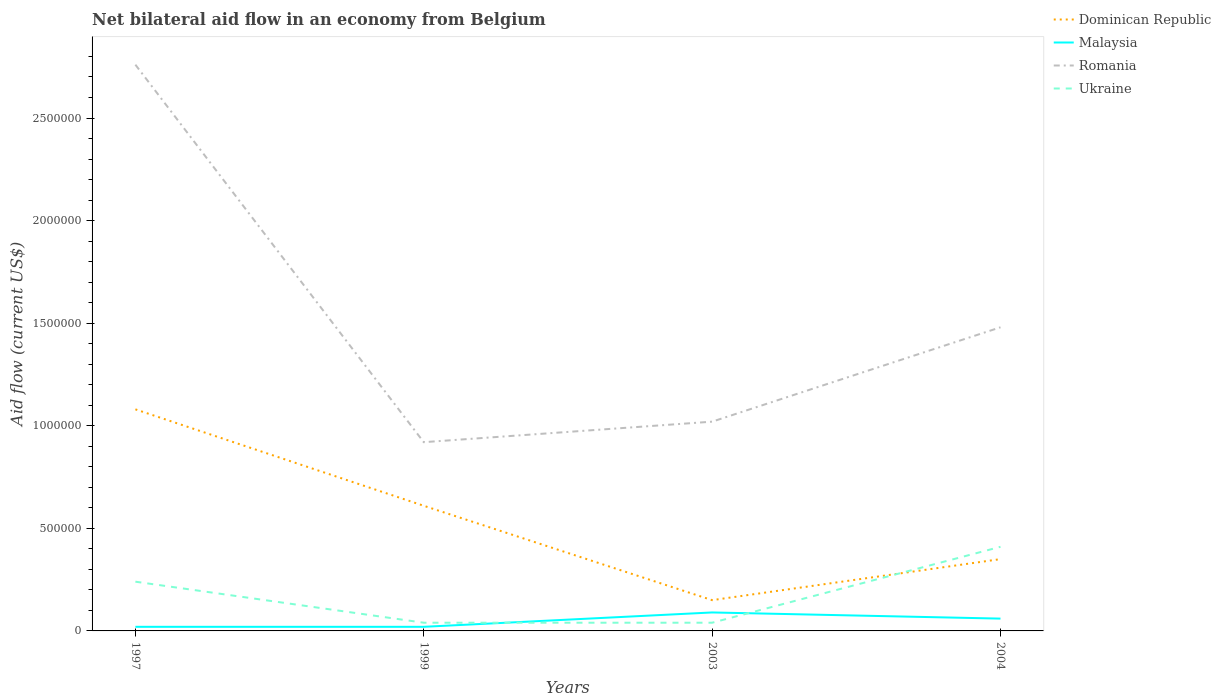Does the line corresponding to Malaysia intersect with the line corresponding to Dominican Republic?
Ensure brevity in your answer.  No. What is the total net bilateral aid flow in Romania in the graph?
Your answer should be compact. 1.84e+06. What is the difference between the highest and the second highest net bilateral aid flow in Romania?
Offer a terse response. 1.84e+06. Is the net bilateral aid flow in Ukraine strictly greater than the net bilateral aid flow in Dominican Republic over the years?
Provide a succinct answer. No. What is the difference between two consecutive major ticks on the Y-axis?
Give a very brief answer. 5.00e+05. Does the graph contain grids?
Make the answer very short. No. Where does the legend appear in the graph?
Your answer should be compact. Top right. How many legend labels are there?
Ensure brevity in your answer.  4. What is the title of the graph?
Your answer should be compact. Net bilateral aid flow in an economy from Belgium. Does "Lesotho" appear as one of the legend labels in the graph?
Give a very brief answer. No. What is the label or title of the X-axis?
Your answer should be very brief. Years. What is the Aid flow (current US$) in Dominican Republic in 1997?
Offer a terse response. 1.08e+06. What is the Aid flow (current US$) in Romania in 1997?
Provide a short and direct response. 2.76e+06. What is the Aid flow (current US$) of Romania in 1999?
Provide a succinct answer. 9.20e+05. What is the Aid flow (current US$) of Ukraine in 1999?
Keep it short and to the point. 4.00e+04. What is the Aid flow (current US$) in Dominican Republic in 2003?
Offer a very short reply. 1.50e+05. What is the Aid flow (current US$) in Romania in 2003?
Your answer should be very brief. 1.02e+06. What is the Aid flow (current US$) of Dominican Republic in 2004?
Give a very brief answer. 3.50e+05. What is the Aid flow (current US$) in Malaysia in 2004?
Make the answer very short. 6.00e+04. What is the Aid flow (current US$) in Romania in 2004?
Your answer should be very brief. 1.48e+06. Across all years, what is the maximum Aid flow (current US$) in Dominican Republic?
Your answer should be very brief. 1.08e+06. Across all years, what is the maximum Aid flow (current US$) of Malaysia?
Provide a succinct answer. 9.00e+04. Across all years, what is the maximum Aid flow (current US$) in Romania?
Keep it short and to the point. 2.76e+06. Across all years, what is the maximum Aid flow (current US$) in Ukraine?
Offer a very short reply. 4.10e+05. Across all years, what is the minimum Aid flow (current US$) of Dominican Republic?
Keep it short and to the point. 1.50e+05. Across all years, what is the minimum Aid flow (current US$) of Malaysia?
Provide a succinct answer. 2.00e+04. Across all years, what is the minimum Aid flow (current US$) in Romania?
Ensure brevity in your answer.  9.20e+05. Across all years, what is the minimum Aid flow (current US$) of Ukraine?
Ensure brevity in your answer.  4.00e+04. What is the total Aid flow (current US$) in Dominican Republic in the graph?
Offer a terse response. 2.19e+06. What is the total Aid flow (current US$) of Malaysia in the graph?
Ensure brevity in your answer.  1.90e+05. What is the total Aid flow (current US$) in Romania in the graph?
Keep it short and to the point. 6.18e+06. What is the total Aid flow (current US$) in Ukraine in the graph?
Give a very brief answer. 7.30e+05. What is the difference between the Aid flow (current US$) in Dominican Republic in 1997 and that in 1999?
Your response must be concise. 4.70e+05. What is the difference between the Aid flow (current US$) of Romania in 1997 and that in 1999?
Keep it short and to the point. 1.84e+06. What is the difference between the Aid flow (current US$) in Ukraine in 1997 and that in 1999?
Your response must be concise. 2.00e+05. What is the difference between the Aid flow (current US$) in Dominican Republic in 1997 and that in 2003?
Your response must be concise. 9.30e+05. What is the difference between the Aid flow (current US$) of Malaysia in 1997 and that in 2003?
Make the answer very short. -7.00e+04. What is the difference between the Aid flow (current US$) in Romania in 1997 and that in 2003?
Give a very brief answer. 1.74e+06. What is the difference between the Aid flow (current US$) in Ukraine in 1997 and that in 2003?
Your response must be concise. 2.00e+05. What is the difference between the Aid flow (current US$) of Dominican Republic in 1997 and that in 2004?
Make the answer very short. 7.30e+05. What is the difference between the Aid flow (current US$) of Romania in 1997 and that in 2004?
Ensure brevity in your answer.  1.28e+06. What is the difference between the Aid flow (current US$) in Dominican Republic in 1999 and that in 2003?
Provide a succinct answer. 4.60e+05. What is the difference between the Aid flow (current US$) in Romania in 1999 and that in 2003?
Offer a very short reply. -1.00e+05. What is the difference between the Aid flow (current US$) of Ukraine in 1999 and that in 2003?
Provide a succinct answer. 0. What is the difference between the Aid flow (current US$) of Malaysia in 1999 and that in 2004?
Give a very brief answer. -4.00e+04. What is the difference between the Aid flow (current US$) in Romania in 1999 and that in 2004?
Provide a succinct answer. -5.60e+05. What is the difference between the Aid flow (current US$) of Ukraine in 1999 and that in 2004?
Give a very brief answer. -3.70e+05. What is the difference between the Aid flow (current US$) of Dominican Republic in 2003 and that in 2004?
Keep it short and to the point. -2.00e+05. What is the difference between the Aid flow (current US$) of Malaysia in 2003 and that in 2004?
Your response must be concise. 3.00e+04. What is the difference between the Aid flow (current US$) in Romania in 2003 and that in 2004?
Ensure brevity in your answer.  -4.60e+05. What is the difference between the Aid flow (current US$) of Ukraine in 2003 and that in 2004?
Provide a succinct answer. -3.70e+05. What is the difference between the Aid flow (current US$) of Dominican Republic in 1997 and the Aid flow (current US$) of Malaysia in 1999?
Make the answer very short. 1.06e+06. What is the difference between the Aid flow (current US$) of Dominican Republic in 1997 and the Aid flow (current US$) of Ukraine in 1999?
Your response must be concise. 1.04e+06. What is the difference between the Aid flow (current US$) in Malaysia in 1997 and the Aid flow (current US$) in Romania in 1999?
Your response must be concise. -9.00e+05. What is the difference between the Aid flow (current US$) in Romania in 1997 and the Aid flow (current US$) in Ukraine in 1999?
Keep it short and to the point. 2.72e+06. What is the difference between the Aid flow (current US$) of Dominican Republic in 1997 and the Aid flow (current US$) of Malaysia in 2003?
Your response must be concise. 9.90e+05. What is the difference between the Aid flow (current US$) in Dominican Republic in 1997 and the Aid flow (current US$) in Romania in 2003?
Give a very brief answer. 6.00e+04. What is the difference between the Aid flow (current US$) of Dominican Republic in 1997 and the Aid flow (current US$) of Ukraine in 2003?
Make the answer very short. 1.04e+06. What is the difference between the Aid flow (current US$) in Malaysia in 1997 and the Aid flow (current US$) in Romania in 2003?
Offer a terse response. -1.00e+06. What is the difference between the Aid flow (current US$) in Romania in 1997 and the Aid flow (current US$) in Ukraine in 2003?
Provide a succinct answer. 2.72e+06. What is the difference between the Aid flow (current US$) of Dominican Republic in 1997 and the Aid flow (current US$) of Malaysia in 2004?
Your answer should be compact. 1.02e+06. What is the difference between the Aid flow (current US$) in Dominican Republic in 1997 and the Aid flow (current US$) in Romania in 2004?
Offer a terse response. -4.00e+05. What is the difference between the Aid flow (current US$) of Dominican Republic in 1997 and the Aid flow (current US$) of Ukraine in 2004?
Ensure brevity in your answer.  6.70e+05. What is the difference between the Aid flow (current US$) of Malaysia in 1997 and the Aid flow (current US$) of Romania in 2004?
Ensure brevity in your answer.  -1.46e+06. What is the difference between the Aid flow (current US$) of Malaysia in 1997 and the Aid flow (current US$) of Ukraine in 2004?
Give a very brief answer. -3.90e+05. What is the difference between the Aid flow (current US$) in Romania in 1997 and the Aid flow (current US$) in Ukraine in 2004?
Your response must be concise. 2.35e+06. What is the difference between the Aid flow (current US$) of Dominican Republic in 1999 and the Aid flow (current US$) of Malaysia in 2003?
Ensure brevity in your answer.  5.20e+05. What is the difference between the Aid flow (current US$) of Dominican Republic in 1999 and the Aid flow (current US$) of Romania in 2003?
Offer a terse response. -4.10e+05. What is the difference between the Aid flow (current US$) of Dominican Republic in 1999 and the Aid flow (current US$) of Ukraine in 2003?
Offer a very short reply. 5.70e+05. What is the difference between the Aid flow (current US$) in Malaysia in 1999 and the Aid flow (current US$) in Romania in 2003?
Offer a terse response. -1.00e+06. What is the difference between the Aid flow (current US$) of Malaysia in 1999 and the Aid flow (current US$) of Ukraine in 2003?
Ensure brevity in your answer.  -2.00e+04. What is the difference between the Aid flow (current US$) of Romania in 1999 and the Aid flow (current US$) of Ukraine in 2003?
Your answer should be very brief. 8.80e+05. What is the difference between the Aid flow (current US$) of Dominican Republic in 1999 and the Aid flow (current US$) of Malaysia in 2004?
Your answer should be very brief. 5.50e+05. What is the difference between the Aid flow (current US$) in Dominican Republic in 1999 and the Aid flow (current US$) in Romania in 2004?
Keep it short and to the point. -8.70e+05. What is the difference between the Aid flow (current US$) of Dominican Republic in 1999 and the Aid flow (current US$) of Ukraine in 2004?
Your answer should be compact. 2.00e+05. What is the difference between the Aid flow (current US$) of Malaysia in 1999 and the Aid flow (current US$) of Romania in 2004?
Ensure brevity in your answer.  -1.46e+06. What is the difference between the Aid flow (current US$) in Malaysia in 1999 and the Aid flow (current US$) in Ukraine in 2004?
Your answer should be very brief. -3.90e+05. What is the difference between the Aid flow (current US$) in Romania in 1999 and the Aid flow (current US$) in Ukraine in 2004?
Keep it short and to the point. 5.10e+05. What is the difference between the Aid flow (current US$) in Dominican Republic in 2003 and the Aid flow (current US$) in Malaysia in 2004?
Keep it short and to the point. 9.00e+04. What is the difference between the Aid flow (current US$) of Dominican Republic in 2003 and the Aid flow (current US$) of Romania in 2004?
Your answer should be very brief. -1.33e+06. What is the difference between the Aid flow (current US$) in Malaysia in 2003 and the Aid flow (current US$) in Romania in 2004?
Give a very brief answer. -1.39e+06. What is the difference between the Aid flow (current US$) in Malaysia in 2003 and the Aid flow (current US$) in Ukraine in 2004?
Make the answer very short. -3.20e+05. What is the average Aid flow (current US$) of Dominican Republic per year?
Ensure brevity in your answer.  5.48e+05. What is the average Aid flow (current US$) of Malaysia per year?
Keep it short and to the point. 4.75e+04. What is the average Aid flow (current US$) in Romania per year?
Provide a short and direct response. 1.54e+06. What is the average Aid flow (current US$) of Ukraine per year?
Make the answer very short. 1.82e+05. In the year 1997, what is the difference between the Aid flow (current US$) in Dominican Republic and Aid flow (current US$) in Malaysia?
Keep it short and to the point. 1.06e+06. In the year 1997, what is the difference between the Aid flow (current US$) in Dominican Republic and Aid flow (current US$) in Romania?
Give a very brief answer. -1.68e+06. In the year 1997, what is the difference between the Aid flow (current US$) of Dominican Republic and Aid flow (current US$) of Ukraine?
Your answer should be compact. 8.40e+05. In the year 1997, what is the difference between the Aid flow (current US$) in Malaysia and Aid flow (current US$) in Romania?
Provide a short and direct response. -2.74e+06. In the year 1997, what is the difference between the Aid flow (current US$) in Romania and Aid flow (current US$) in Ukraine?
Your answer should be compact. 2.52e+06. In the year 1999, what is the difference between the Aid flow (current US$) of Dominican Republic and Aid flow (current US$) of Malaysia?
Give a very brief answer. 5.90e+05. In the year 1999, what is the difference between the Aid flow (current US$) of Dominican Republic and Aid flow (current US$) of Romania?
Offer a very short reply. -3.10e+05. In the year 1999, what is the difference between the Aid flow (current US$) in Dominican Republic and Aid flow (current US$) in Ukraine?
Your answer should be very brief. 5.70e+05. In the year 1999, what is the difference between the Aid flow (current US$) in Malaysia and Aid flow (current US$) in Romania?
Your answer should be compact. -9.00e+05. In the year 1999, what is the difference between the Aid flow (current US$) in Malaysia and Aid flow (current US$) in Ukraine?
Offer a terse response. -2.00e+04. In the year 1999, what is the difference between the Aid flow (current US$) of Romania and Aid flow (current US$) of Ukraine?
Offer a terse response. 8.80e+05. In the year 2003, what is the difference between the Aid flow (current US$) of Dominican Republic and Aid flow (current US$) of Malaysia?
Keep it short and to the point. 6.00e+04. In the year 2003, what is the difference between the Aid flow (current US$) in Dominican Republic and Aid flow (current US$) in Romania?
Give a very brief answer. -8.70e+05. In the year 2003, what is the difference between the Aid flow (current US$) of Dominican Republic and Aid flow (current US$) of Ukraine?
Your answer should be compact. 1.10e+05. In the year 2003, what is the difference between the Aid flow (current US$) of Malaysia and Aid flow (current US$) of Romania?
Make the answer very short. -9.30e+05. In the year 2003, what is the difference between the Aid flow (current US$) of Romania and Aid flow (current US$) of Ukraine?
Your answer should be compact. 9.80e+05. In the year 2004, what is the difference between the Aid flow (current US$) in Dominican Republic and Aid flow (current US$) in Malaysia?
Your answer should be compact. 2.90e+05. In the year 2004, what is the difference between the Aid flow (current US$) in Dominican Republic and Aid flow (current US$) in Romania?
Your response must be concise. -1.13e+06. In the year 2004, what is the difference between the Aid flow (current US$) of Malaysia and Aid flow (current US$) of Romania?
Provide a succinct answer. -1.42e+06. In the year 2004, what is the difference between the Aid flow (current US$) of Malaysia and Aid flow (current US$) of Ukraine?
Your answer should be compact. -3.50e+05. In the year 2004, what is the difference between the Aid flow (current US$) in Romania and Aid flow (current US$) in Ukraine?
Your answer should be compact. 1.07e+06. What is the ratio of the Aid flow (current US$) of Dominican Republic in 1997 to that in 1999?
Provide a succinct answer. 1.77. What is the ratio of the Aid flow (current US$) of Romania in 1997 to that in 1999?
Provide a short and direct response. 3. What is the ratio of the Aid flow (current US$) of Ukraine in 1997 to that in 1999?
Ensure brevity in your answer.  6. What is the ratio of the Aid flow (current US$) of Malaysia in 1997 to that in 2003?
Keep it short and to the point. 0.22. What is the ratio of the Aid flow (current US$) of Romania in 1997 to that in 2003?
Your answer should be very brief. 2.71. What is the ratio of the Aid flow (current US$) in Ukraine in 1997 to that in 2003?
Make the answer very short. 6. What is the ratio of the Aid flow (current US$) of Dominican Republic in 1997 to that in 2004?
Your answer should be very brief. 3.09. What is the ratio of the Aid flow (current US$) in Malaysia in 1997 to that in 2004?
Keep it short and to the point. 0.33. What is the ratio of the Aid flow (current US$) in Romania in 1997 to that in 2004?
Your answer should be compact. 1.86. What is the ratio of the Aid flow (current US$) of Ukraine in 1997 to that in 2004?
Your answer should be very brief. 0.59. What is the ratio of the Aid flow (current US$) of Dominican Republic in 1999 to that in 2003?
Keep it short and to the point. 4.07. What is the ratio of the Aid flow (current US$) of Malaysia in 1999 to that in 2003?
Offer a terse response. 0.22. What is the ratio of the Aid flow (current US$) of Romania in 1999 to that in 2003?
Provide a short and direct response. 0.9. What is the ratio of the Aid flow (current US$) of Ukraine in 1999 to that in 2003?
Your response must be concise. 1. What is the ratio of the Aid flow (current US$) of Dominican Republic in 1999 to that in 2004?
Offer a very short reply. 1.74. What is the ratio of the Aid flow (current US$) in Romania in 1999 to that in 2004?
Provide a succinct answer. 0.62. What is the ratio of the Aid flow (current US$) in Ukraine in 1999 to that in 2004?
Offer a terse response. 0.1. What is the ratio of the Aid flow (current US$) of Dominican Republic in 2003 to that in 2004?
Provide a short and direct response. 0.43. What is the ratio of the Aid flow (current US$) of Malaysia in 2003 to that in 2004?
Offer a very short reply. 1.5. What is the ratio of the Aid flow (current US$) in Romania in 2003 to that in 2004?
Your response must be concise. 0.69. What is the ratio of the Aid flow (current US$) in Ukraine in 2003 to that in 2004?
Ensure brevity in your answer.  0.1. What is the difference between the highest and the second highest Aid flow (current US$) in Malaysia?
Make the answer very short. 3.00e+04. What is the difference between the highest and the second highest Aid flow (current US$) of Romania?
Provide a short and direct response. 1.28e+06. What is the difference between the highest and the second highest Aid flow (current US$) of Ukraine?
Provide a succinct answer. 1.70e+05. What is the difference between the highest and the lowest Aid flow (current US$) in Dominican Republic?
Keep it short and to the point. 9.30e+05. What is the difference between the highest and the lowest Aid flow (current US$) in Romania?
Ensure brevity in your answer.  1.84e+06. What is the difference between the highest and the lowest Aid flow (current US$) in Ukraine?
Offer a terse response. 3.70e+05. 